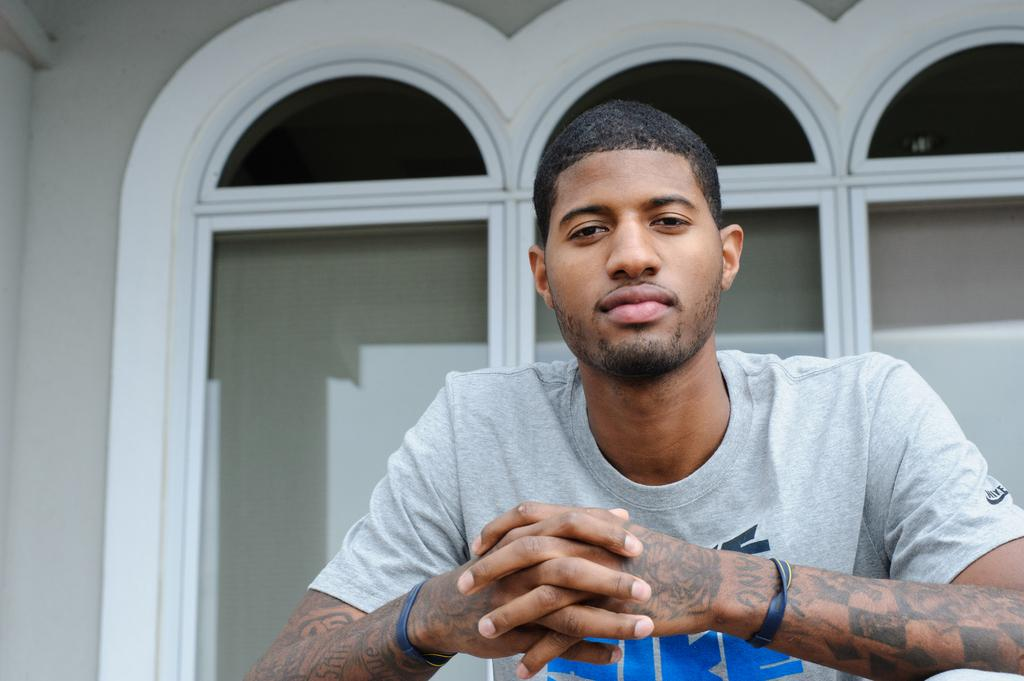Who is present in the image? There is a man in the image. What can be seen in the background of the image? There are windows visible in the background of the image. What type of button is being used to express hate in the image? There is no button or expression of hate present in the image. 